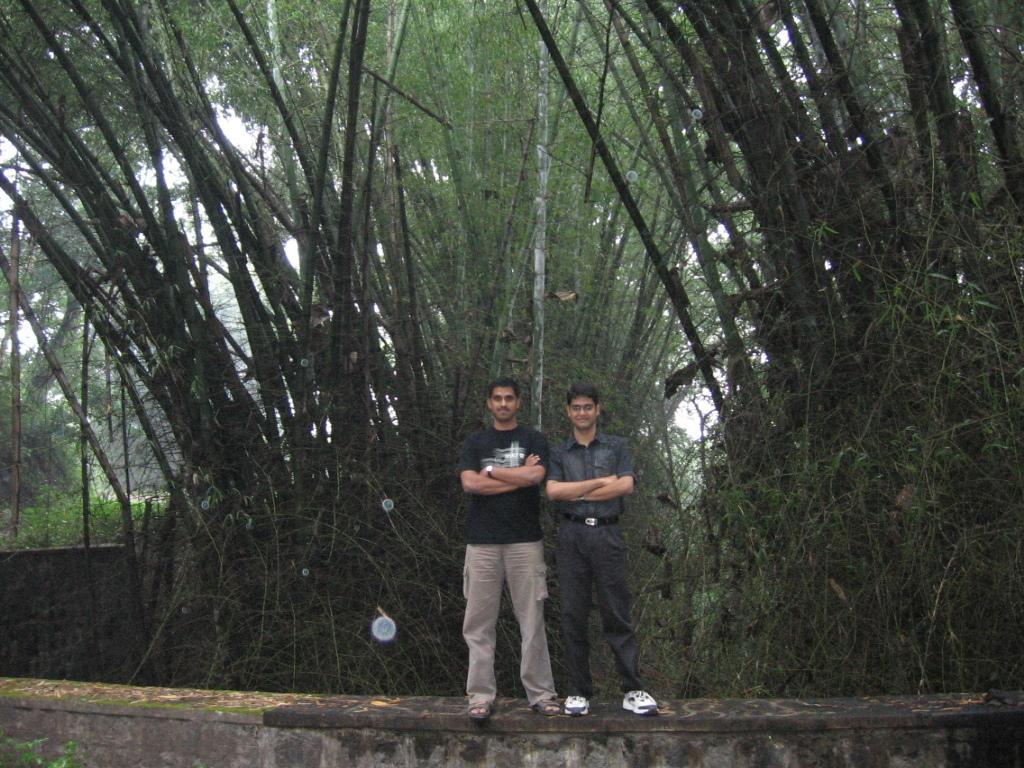In one or two sentences, can you explain what this image depicts? In this image we can see two men are standing on the wall. One man is wearing a black color T-shirt with pant and the other one is wearing a shirt and pant. Behind them, we can see so many trees. Behind the trees, there is the white color sky. 